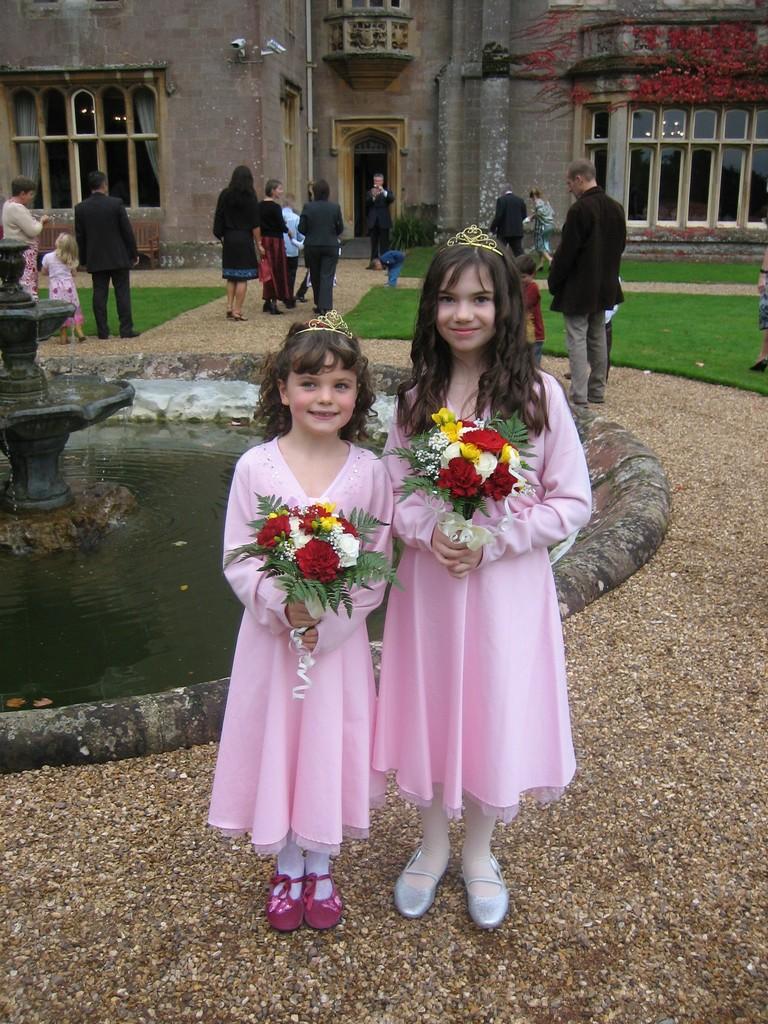Can you describe this image briefly? In this image we can see two children standing on the ground and carrying garlands in their hands. In the background we can see persons standing on the ground, fountain, water, ground, tree, building, cc cameras and windows. 